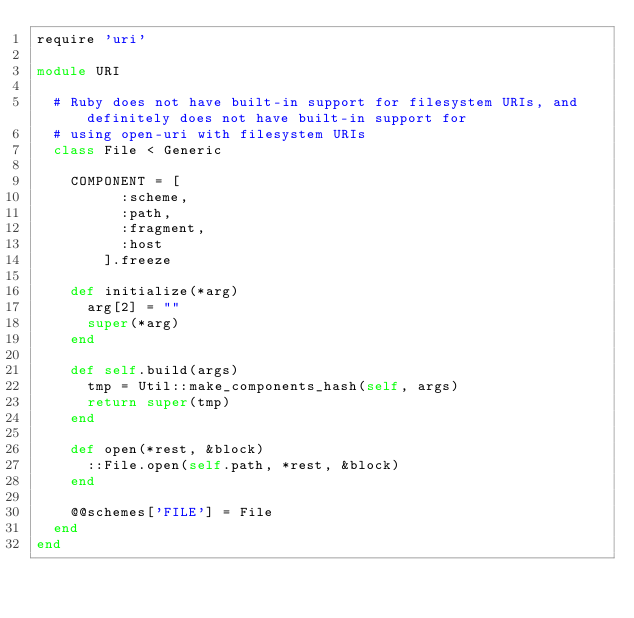Convert code to text. <code><loc_0><loc_0><loc_500><loc_500><_Ruby_>require 'uri'

module URI

  # Ruby does not have built-in support for filesystem URIs, and definitely does not have built-in support for
  # using open-uri with filesystem URIs
  class File < Generic
    
    COMPONENT = [
          :scheme,  
          :path, 
          :fragment,
          :host
        ].freeze
        
    def initialize(*arg)
      arg[2] = ""
      super(*arg)
    end
    
    def self.build(args)
      tmp = Util::make_components_hash(self, args)
      return super(tmp)
    end
    
    def open(*rest, &block)
      ::File.open(self.path, *rest, &block)
    end
    
    @@schemes['FILE'] = File
  end
end</code> 